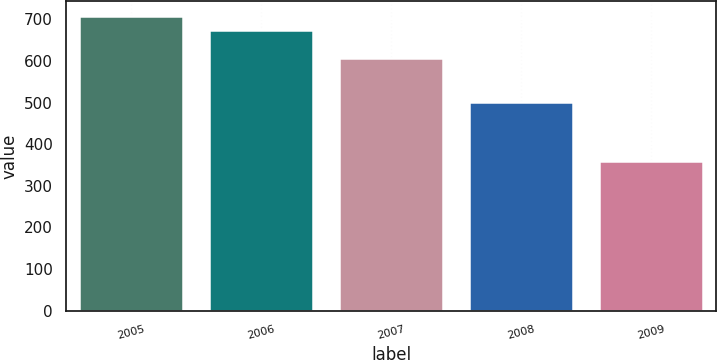<chart> <loc_0><loc_0><loc_500><loc_500><bar_chart><fcel>2005<fcel>2006<fcel>2007<fcel>2008<fcel>2009<nl><fcel>708.1<fcel>674<fcel>606<fcel>502<fcel>360<nl></chart> 